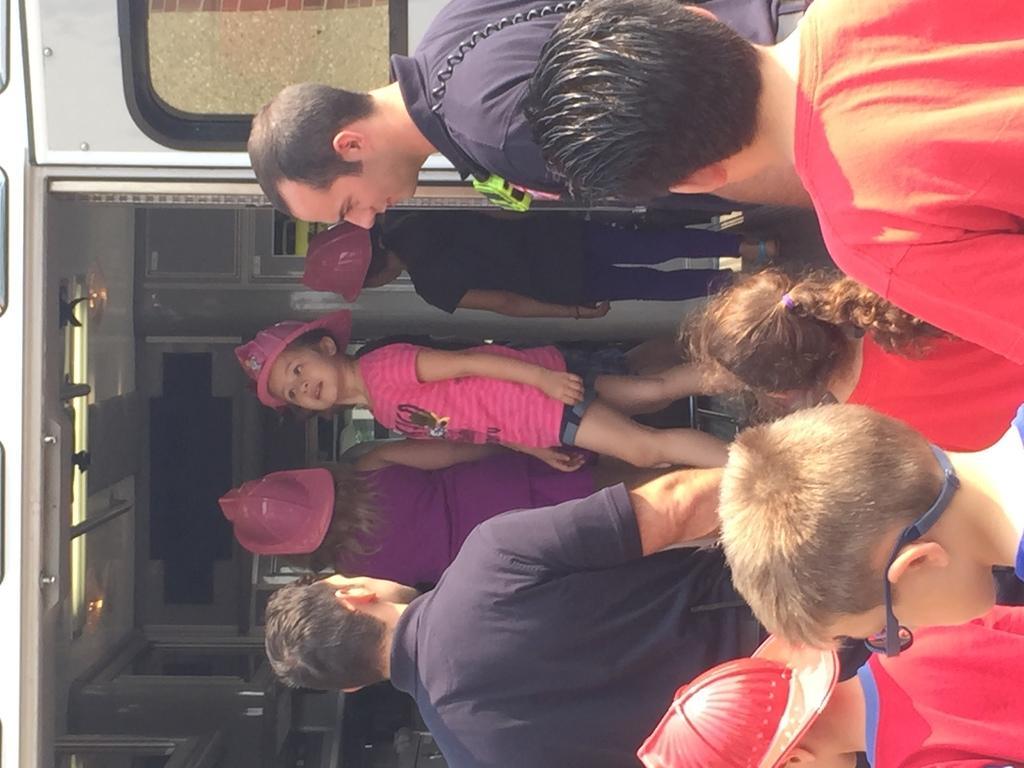Can you describe this image briefly? In this image we can see two men and children. On the left side of the image, it seems like vehicle. In the vehicle, we can see three girls. 